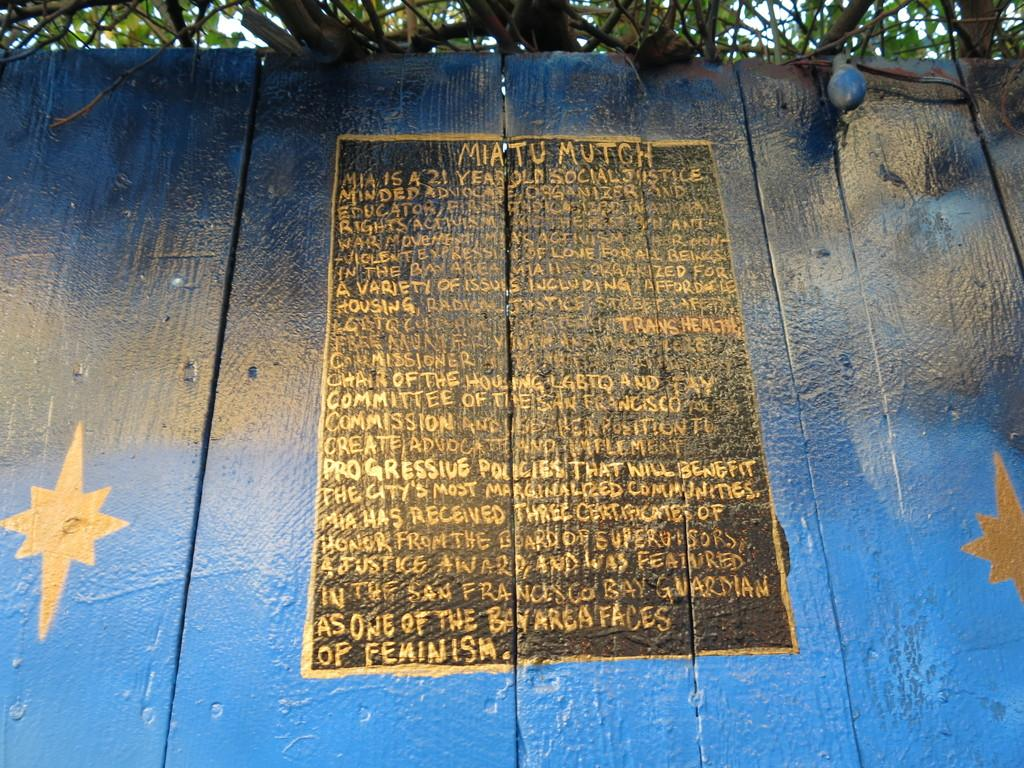What type of vegetation can be seen in the image? There are trees visible towards the top of the image. What material is used for the wall in the image? There is a wooden wall towards the bottom of the image. Is there any text or writing present in the image? Yes, there is text on the wooden wall. What type of creature is standing next to the wooden wall in the image? There is no creature present in the image; it only features trees and a wooden wall with text. How many pages of text are visible on the wooden wall in the image? There is no reference to pages in the image, as the text is on a wooden wall, not a book or document. 